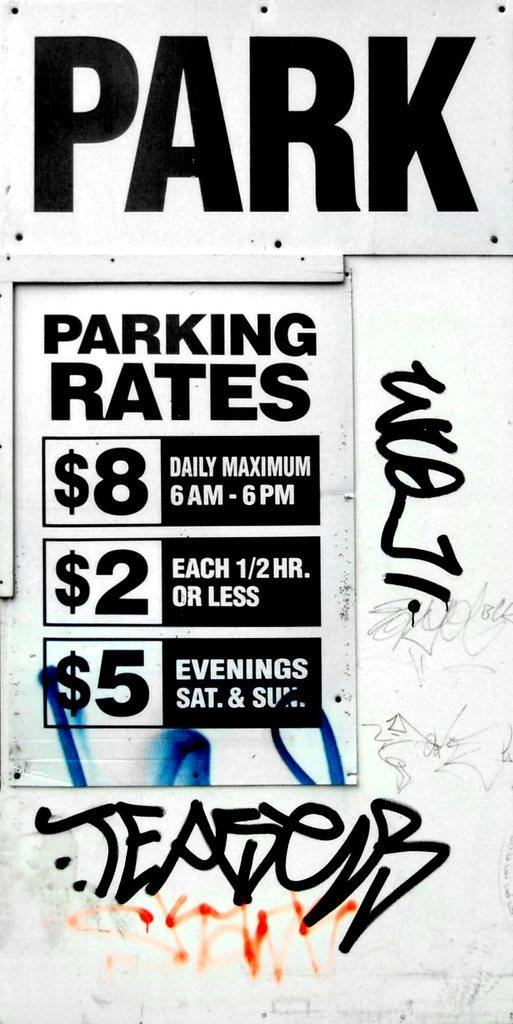<image>
Relay a brief, clear account of the picture shown. A sign showing 3 different parking rates with graffiti on it. 